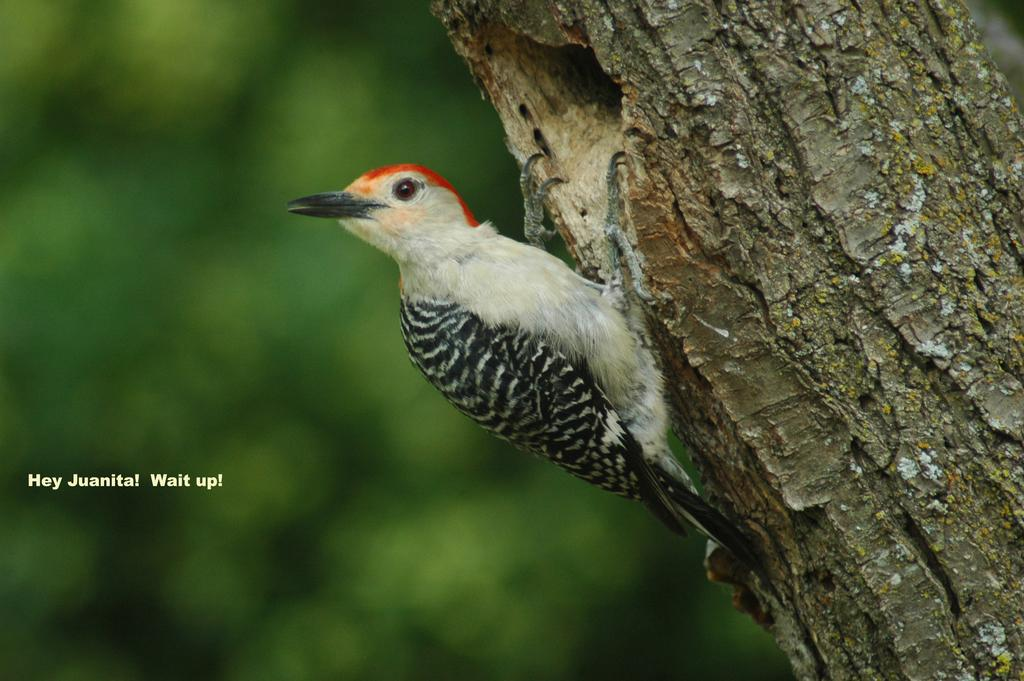What type of animal is in the picture? There is a small bird in the picture. Where is the bird located? The bird is standing on a tree trunk. What color is the background of the bird? The background of the bird is blue. What note is the minister playing on the kettle in the image? There is no minister or kettle present in the image; it features a small bird standing on a tree trunk with a blue background. 